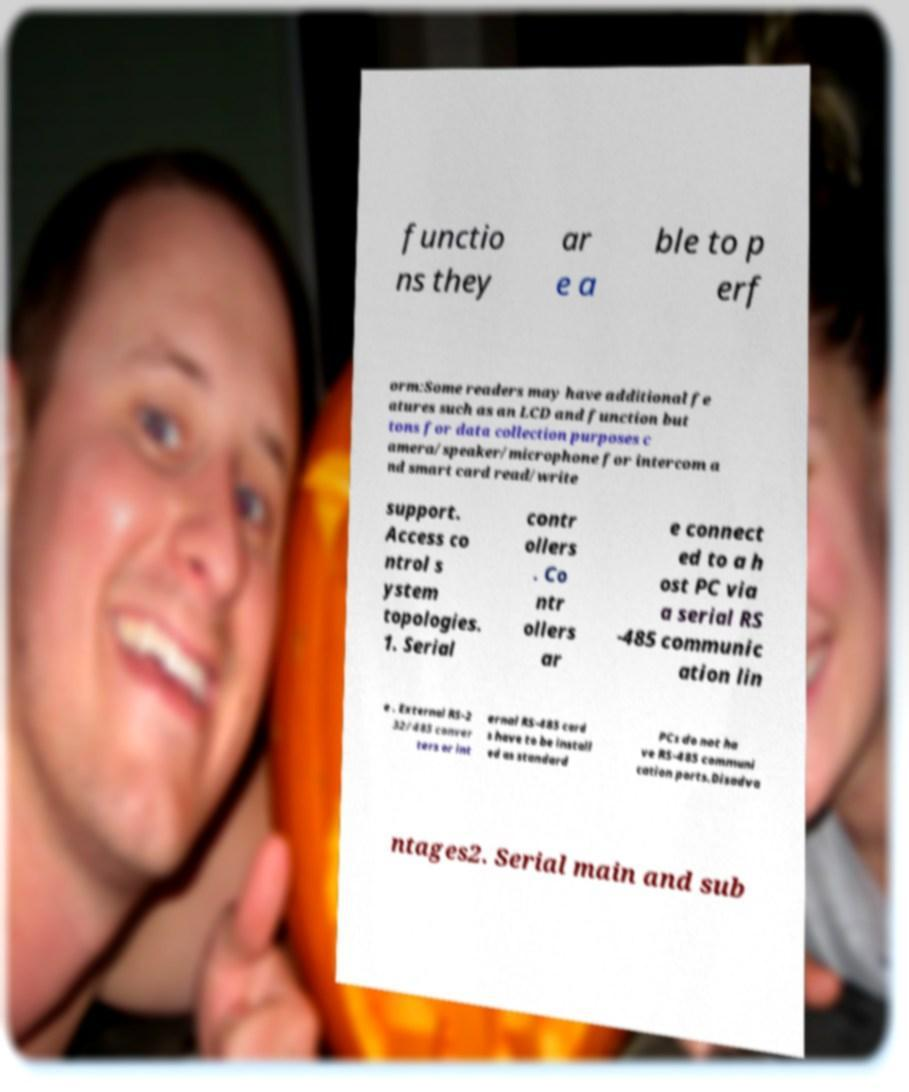What messages or text are displayed in this image? I need them in a readable, typed format. functio ns they ar e a ble to p erf orm:Some readers may have additional fe atures such as an LCD and function but tons for data collection purposes c amera/speaker/microphone for intercom a nd smart card read/write support. Access co ntrol s ystem topologies. 1. Serial contr ollers . Co ntr ollers ar e connect ed to a h ost PC via a serial RS -485 communic ation lin e . External RS-2 32/485 conver ters or int ernal RS-485 card s have to be install ed as standard PCs do not ha ve RS-485 communi cation ports.Disadva ntages2. Serial main and sub 